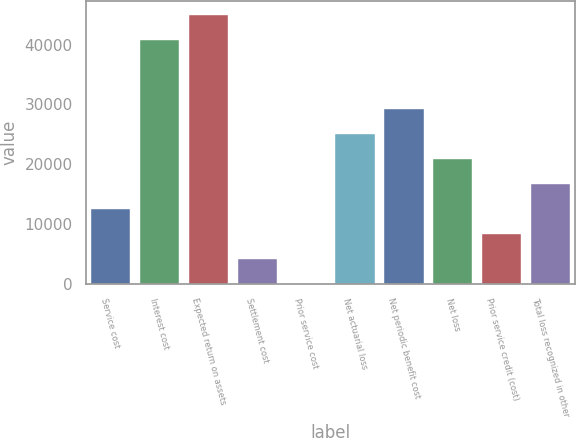<chart> <loc_0><loc_0><loc_500><loc_500><bar_chart><fcel>Service cost<fcel>Interest cost<fcel>Expected return on assets<fcel>Settlement cost<fcel>Prior service cost<fcel>Net actuarial loss<fcel>Net periodic benefit cost<fcel>Net loss<fcel>Prior service credit (cost)<fcel>Total loss recognized in other<nl><fcel>12540.3<fcel>40830<fcel>45007.1<fcel>4186.1<fcel>9<fcel>25071.6<fcel>29248.7<fcel>20894.5<fcel>8363.2<fcel>16717.4<nl></chart> 